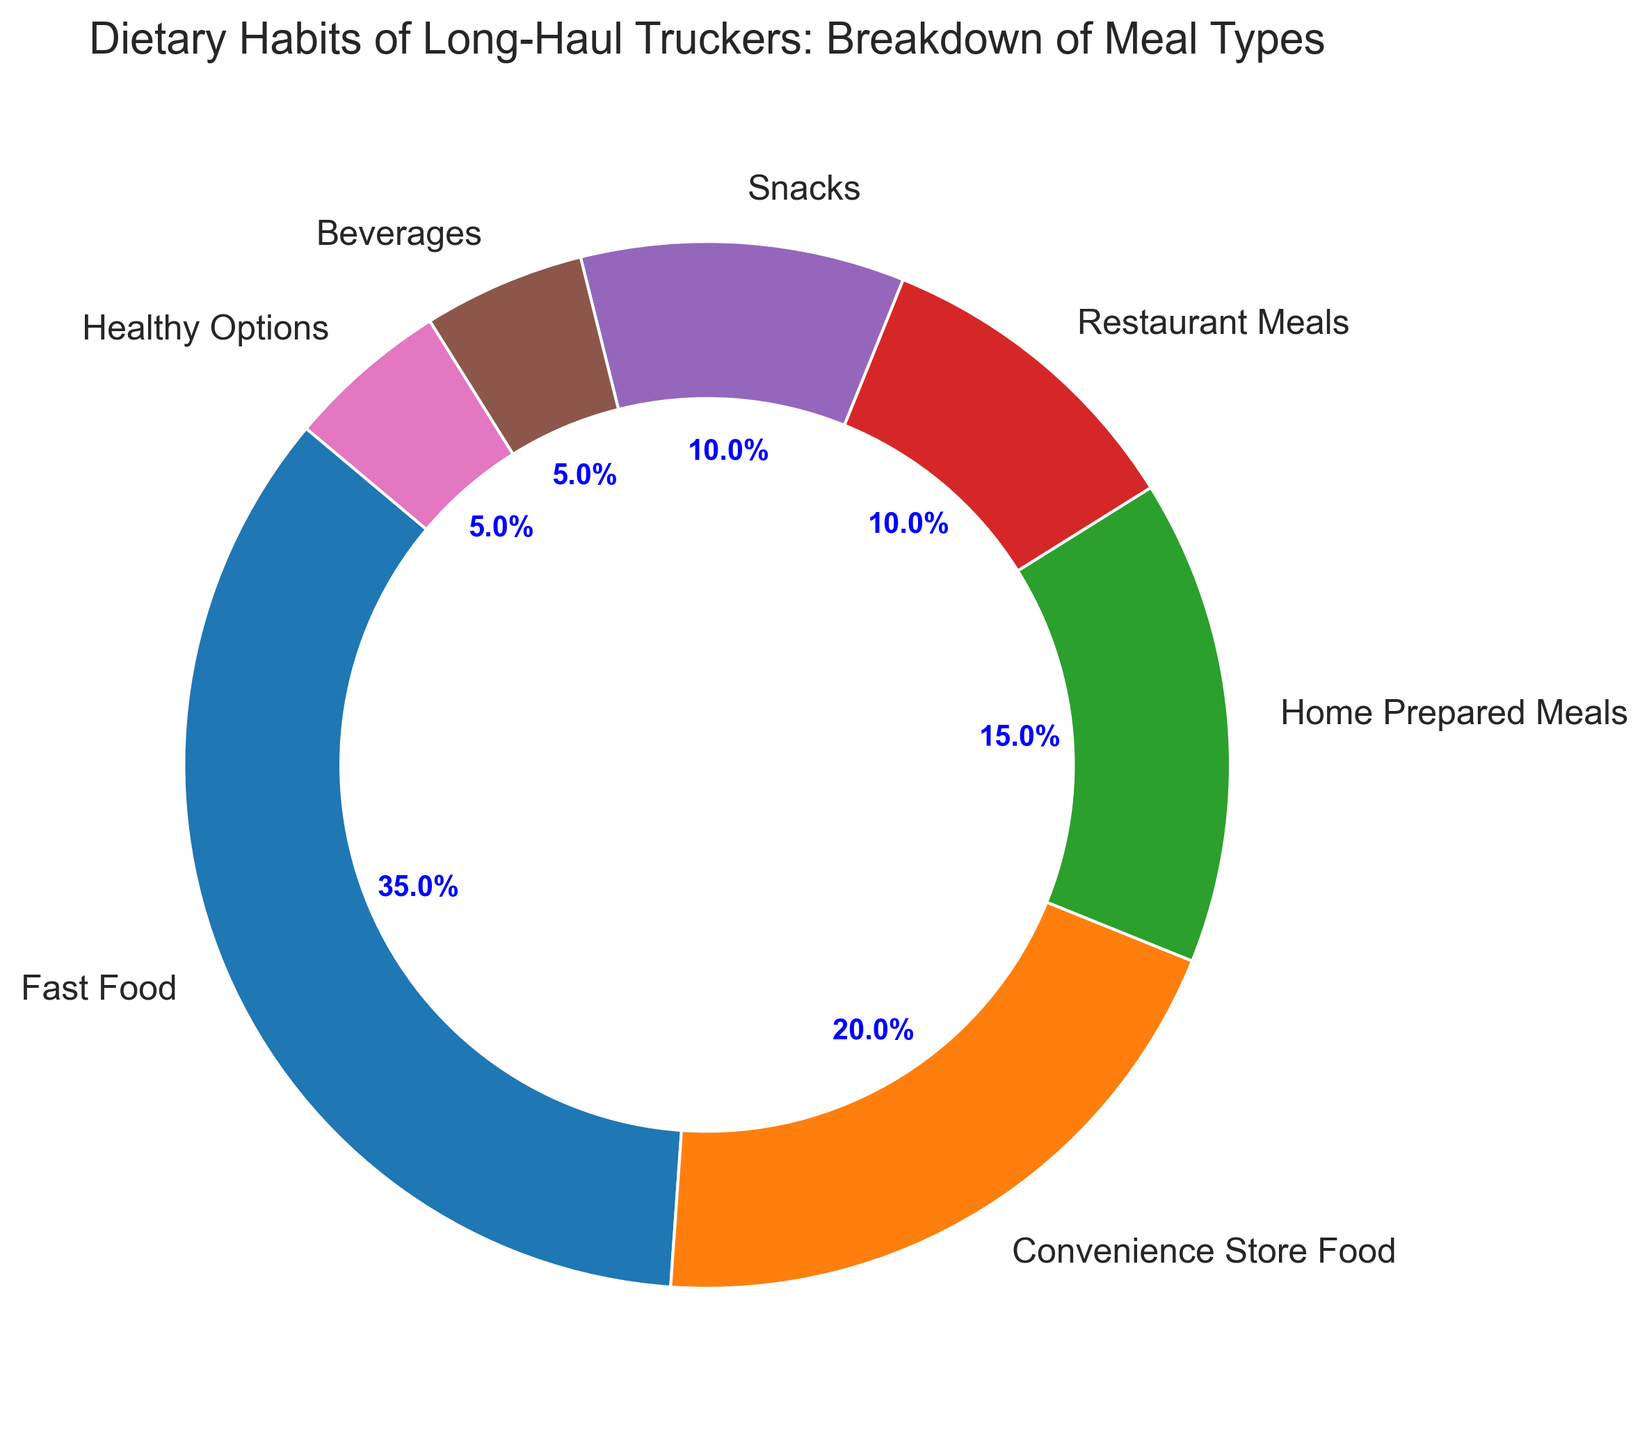What is the most common meal type among long-haul truckers? Find the section with the highest percentage in the ring chart. The largest section represents "Fast Food" with 35%.
Answer: Fast Food What is the total percentage of meals that are home-prepared or healthy options? Sum the percentages of "Home Prepared Meals" and "Healthy Options" (15% + 5%).
Answer: 20% How does the percentage of fast food compare to convenience store food? The "Fast Food" section represents 35%, and the "Convenience Store Food" section represents 20%. Compare the two values.
Answer: Fast Food > Convenience Store Food What is the difference in percentage between restaurant meals and snacks? Determine the difference by subtracting the percentage of "Snacks" from "Restaurant Meals" (10% - 10%).
Answer: 0% Which meal type occupies the smallest section of the ring chart? Find the section with the smallest percentage in the ring chart. The smallest sections are "Beverages" and "Healthy Options," both at 5%.
Answer: Beverages and Healthy Options What is the combined percentage of snack and beverage intake? Sum the percentages of "Snacks" and "Beverages" (10% + 5%).
Answer: 15% What percentage more do truckers eat convenience store food compared to home-prepared meals? Subtract the percentage of "Home Prepared Meals" from "Convenience Store Food" (20% - 15%).
Answer: 5% If we group fast food and restaurant meals together, what would be the combined percentage? Add the percentages of "Fast Food" and "Restaurant Meals" (35% + 10%).
Answer: 45% What percentage of truckers' meals are not home-prepared or healthy options? Subtract the combined percentage of "Home Prepared Meals" and "Healthy Options" from 100% (100% - 20%).
Answer: 80% Considering the smallest and largest meal type percentages, what is the range of the data? Subtract the smallest percentage from the largest percentage (35% - 5%).
Answer: 30% 